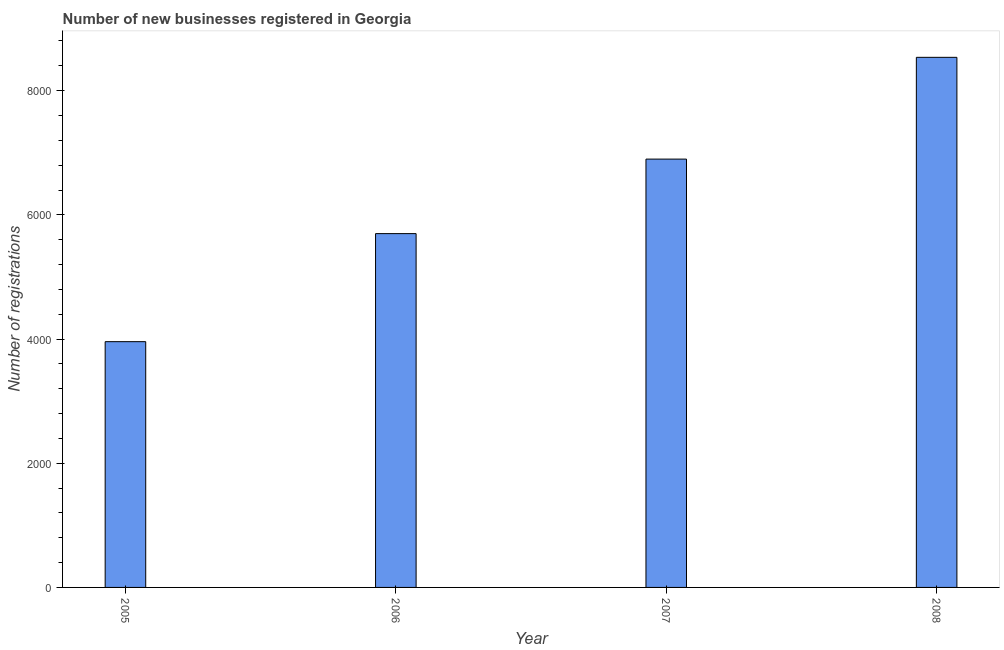What is the title of the graph?
Provide a succinct answer. Number of new businesses registered in Georgia. What is the label or title of the Y-axis?
Your answer should be very brief. Number of registrations. What is the number of new business registrations in 2008?
Give a very brief answer. 8537. Across all years, what is the maximum number of new business registrations?
Provide a short and direct response. 8537. Across all years, what is the minimum number of new business registrations?
Provide a short and direct response. 3958. In which year was the number of new business registrations maximum?
Offer a very short reply. 2008. In which year was the number of new business registrations minimum?
Make the answer very short. 2005. What is the sum of the number of new business registrations?
Ensure brevity in your answer.  2.51e+04. What is the difference between the number of new business registrations in 2007 and 2008?
Give a very brief answer. -1639. What is the average number of new business registrations per year?
Give a very brief answer. 6272. What is the median number of new business registrations?
Provide a succinct answer. 6298. In how many years, is the number of new business registrations greater than 8000 ?
Keep it short and to the point. 1. What is the ratio of the number of new business registrations in 2005 to that in 2007?
Keep it short and to the point. 0.57. Is the number of new business registrations in 2005 less than that in 2006?
Provide a succinct answer. Yes. Is the difference between the number of new business registrations in 2005 and 2008 greater than the difference between any two years?
Your response must be concise. Yes. What is the difference between the highest and the second highest number of new business registrations?
Give a very brief answer. 1639. What is the difference between the highest and the lowest number of new business registrations?
Make the answer very short. 4579. In how many years, is the number of new business registrations greater than the average number of new business registrations taken over all years?
Ensure brevity in your answer.  2. How many years are there in the graph?
Ensure brevity in your answer.  4. What is the difference between two consecutive major ticks on the Y-axis?
Offer a terse response. 2000. What is the Number of registrations in 2005?
Make the answer very short. 3958. What is the Number of registrations in 2006?
Offer a very short reply. 5698. What is the Number of registrations in 2007?
Provide a short and direct response. 6898. What is the Number of registrations of 2008?
Give a very brief answer. 8537. What is the difference between the Number of registrations in 2005 and 2006?
Make the answer very short. -1740. What is the difference between the Number of registrations in 2005 and 2007?
Your answer should be very brief. -2940. What is the difference between the Number of registrations in 2005 and 2008?
Offer a very short reply. -4579. What is the difference between the Number of registrations in 2006 and 2007?
Offer a terse response. -1200. What is the difference between the Number of registrations in 2006 and 2008?
Give a very brief answer. -2839. What is the difference between the Number of registrations in 2007 and 2008?
Keep it short and to the point. -1639. What is the ratio of the Number of registrations in 2005 to that in 2006?
Ensure brevity in your answer.  0.69. What is the ratio of the Number of registrations in 2005 to that in 2007?
Make the answer very short. 0.57. What is the ratio of the Number of registrations in 2005 to that in 2008?
Provide a short and direct response. 0.46. What is the ratio of the Number of registrations in 2006 to that in 2007?
Make the answer very short. 0.83. What is the ratio of the Number of registrations in 2006 to that in 2008?
Provide a short and direct response. 0.67. What is the ratio of the Number of registrations in 2007 to that in 2008?
Your answer should be compact. 0.81. 